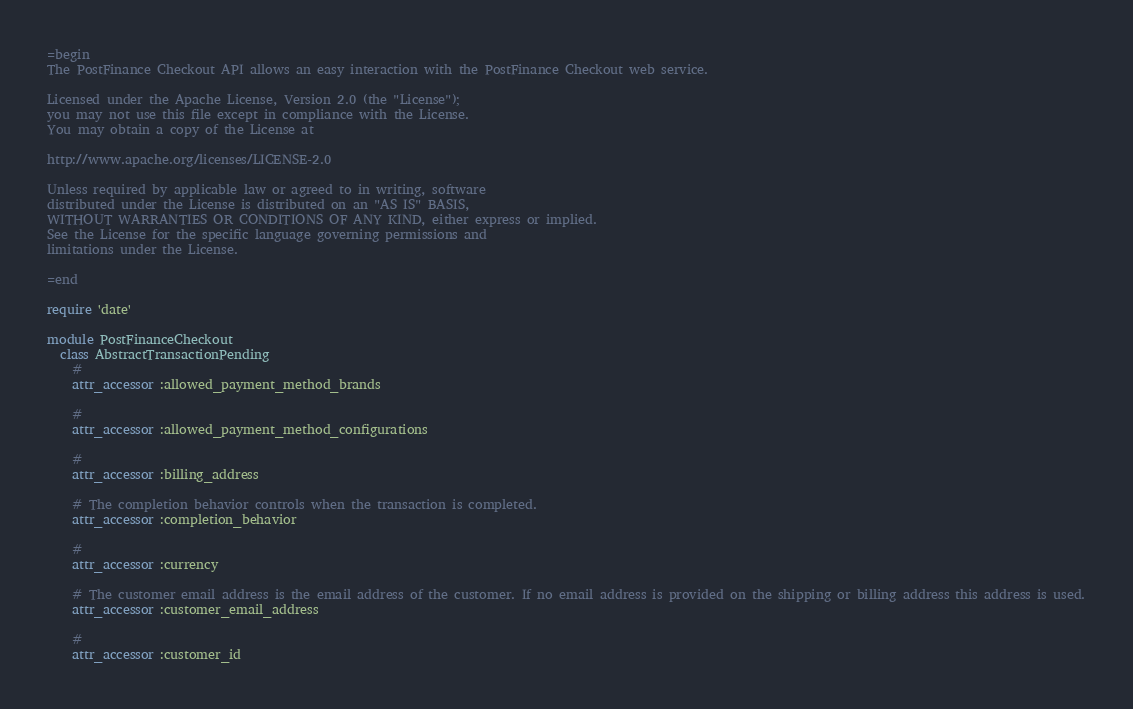Convert code to text. <code><loc_0><loc_0><loc_500><loc_500><_Ruby_>=begin
The PostFinance Checkout API allows an easy interaction with the PostFinance Checkout web service.

Licensed under the Apache License, Version 2.0 (the "License");
you may not use this file except in compliance with the License.
You may obtain a copy of the License at

http://www.apache.org/licenses/LICENSE-2.0

Unless required by applicable law or agreed to in writing, software
distributed under the License is distributed on an "AS IS" BASIS,
WITHOUT WARRANTIES OR CONDITIONS OF ANY KIND, either express or implied.
See the License for the specific language governing permissions and
limitations under the License.

=end

require 'date'

module PostFinanceCheckout
  class AbstractTransactionPending
    # 
    attr_accessor :allowed_payment_method_brands

    # 
    attr_accessor :allowed_payment_method_configurations

    # 
    attr_accessor :billing_address

    # The completion behavior controls when the transaction is completed.
    attr_accessor :completion_behavior

    # 
    attr_accessor :currency

    # The customer email address is the email address of the customer. If no email address is provided on the shipping or billing address this address is used.
    attr_accessor :customer_email_address

    # 
    attr_accessor :customer_id
</code> 